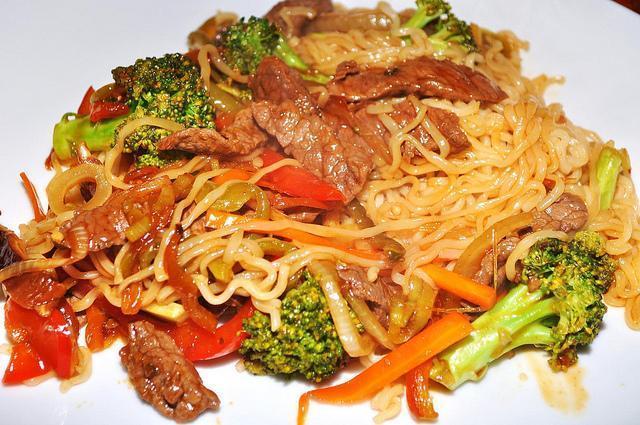How many carrots are there?
Give a very brief answer. 3. How many broccolis are there?
Give a very brief answer. 5. 